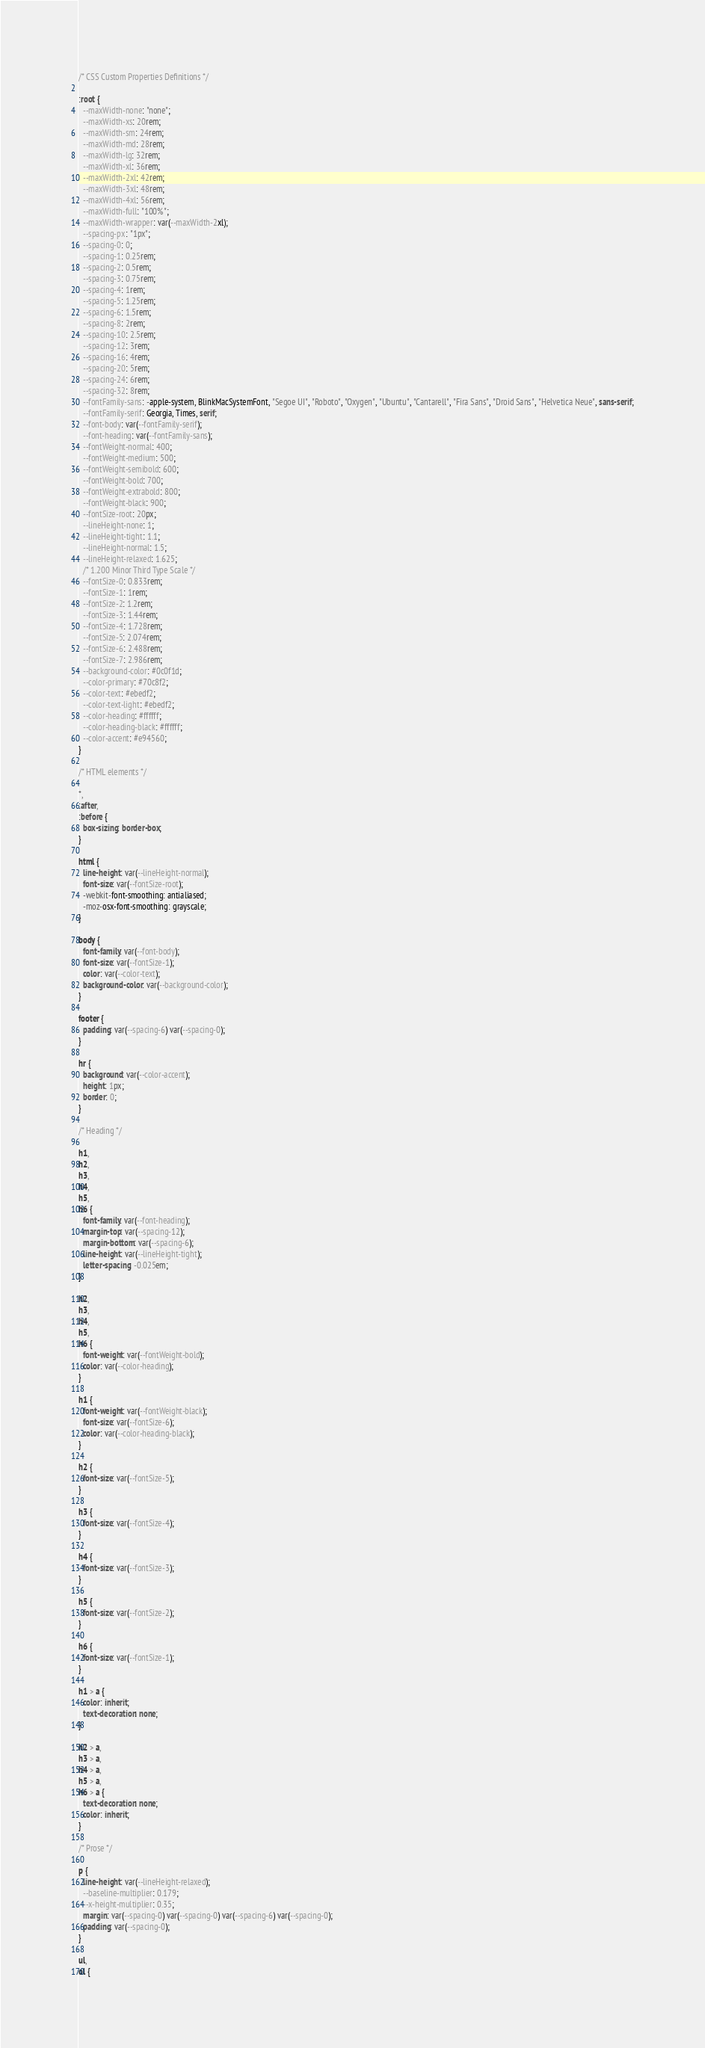Convert code to text. <code><loc_0><loc_0><loc_500><loc_500><_CSS_>/* CSS Custom Properties Definitions */

:root {
  --maxWidth-none: "none";
  --maxWidth-xs: 20rem;
  --maxWidth-sm: 24rem;
  --maxWidth-md: 28rem;
  --maxWidth-lg: 32rem;
  --maxWidth-xl: 36rem;
  --maxWidth-2xl: 42rem;
  --maxWidth-3xl: 48rem;
  --maxWidth-4xl: 56rem;
  --maxWidth-full: "100%";
  --maxWidth-wrapper: var(--maxWidth-2xl);
  --spacing-px: "1px";
  --spacing-0: 0;
  --spacing-1: 0.25rem;
  --spacing-2: 0.5rem;
  --spacing-3: 0.75rem;
  --spacing-4: 1rem;
  --spacing-5: 1.25rem;
  --spacing-6: 1.5rem;
  --spacing-8: 2rem;
  --spacing-10: 2.5rem;
  --spacing-12: 3rem;
  --spacing-16: 4rem;
  --spacing-20: 5rem;
  --spacing-24: 6rem;
  --spacing-32: 8rem;
  --fontFamily-sans: -apple-system, BlinkMacSystemFont, "Segoe UI", "Roboto", "Oxygen", "Ubuntu", "Cantarell", "Fira Sans", "Droid Sans", "Helvetica Neue", sans-serif;
  --fontFamily-serif: Georgia, Times, serif;
  --font-body: var(--fontFamily-serif);
  --font-heading: var(--fontFamily-sans);
  --fontWeight-normal: 400;
  --fontWeight-medium: 500;
  --fontWeight-semibold: 600;
  --fontWeight-bold: 700;
  --fontWeight-extrabold: 800;
  --fontWeight-black: 900;
  --fontSize-root: 20px;
  --lineHeight-none: 1;
  --lineHeight-tight: 1.1;
  --lineHeight-normal: 1.5;
  --lineHeight-relaxed: 1.625;
  /* 1.200 Minor Third Type Scale */
  --fontSize-0: 0.833rem;
  --fontSize-1: 1rem;
  --fontSize-2: 1.2rem;
  --fontSize-3: 1.44rem;
  --fontSize-4: 1.728rem;
  --fontSize-5: 2.074rem;
  --fontSize-6: 2.488rem;
  --fontSize-7: 2.986rem;
  --background-color: #0c0f1d;
  --color-primary: #70c8f2;
  --color-text: #ebedf2;
  --color-text-light: #ebedf2;
  --color-heading: #ffffff;
  --color-heading-black: #ffffff;
  --color-accent: #e94560;
}

/* HTML elements */

*,
:after,
:before {
  box-sizing: border-box;
}

html {
  line-height: var(--lineHeight-normal);
  font-size: var(--fontSize-root);
  -webkit-font-smoothing: antialiased;
  -moz-osx-font-smoothing: grayscale;
}

body {
  font-family: var(--font-body);
  font-size: var(--fontSize-1);
  color: var(--color-text);
  background-color: var(--background-color);
}

footer {
  padding: var(--spacing-6) var(--spacing-0);
}

hr {
  background: var(--color-accent);
  height: 1px;
  border: 0;
}

/* Heading */

h1,
h2,
h3,
h4,
h5,
h6 {
  font-family: var(--font-heading);
  margin-top: var(--spacing-12);
  margin-bottom: var(--spacing-6);
  line-height: var(--lineHeight-tight);
  letter-spacing: -0.025em;
}

h2,
h3,
h4,
h5,
h6 {
  font-weight: var(--fontWeight-bold);
  color: var(--color-heading);
}

h1 {
  font-weight: var(--fontWeight-black);
  font-size: var(--fontSize-6);
  color: var(--color-heading-black);
}

h2 {
  font-size: var(--fontSize-5);
}

h3 {
  font-size: var(--fontSize-4);
}

h4 {
  font-size: var(--fontSize-3);
}

h5 {
  font-size: var(--fontSize-2);
}

h6 {
  font-size: var(--fontSize-1);
}

h1 > a {
  color: inherit;
  text-decoration: none;
}

h2 > a,
h3 > a,
h4 > a,
h5 > a,
h6 > a {
  text-decoration: none;
  color: inherit;
}

/* Prose */

p {
  line-height: var(--lineHeight-relaxed);
  --baseline-multiplier: 0.179;
  --x-height-multiplier: 0.35;
  margin: var(--spacing-0) var(--spacing-0) var(--spacing-6) var(--spacing-0);
  padding: var(--spacing-0);
}

ul,
ol {</code> 